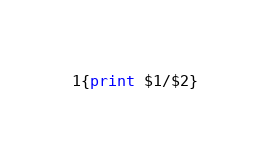<code> <loc_0><loc_0><loc_500><loc_500><_Awk_>{print $1/$2}</code> 